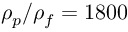Convert formula to latex. <formula><loc_0><loc_0><loc_500><loc_500>\rho _ { p } / \rho _ { f } = 1 8 0 0</formula> 